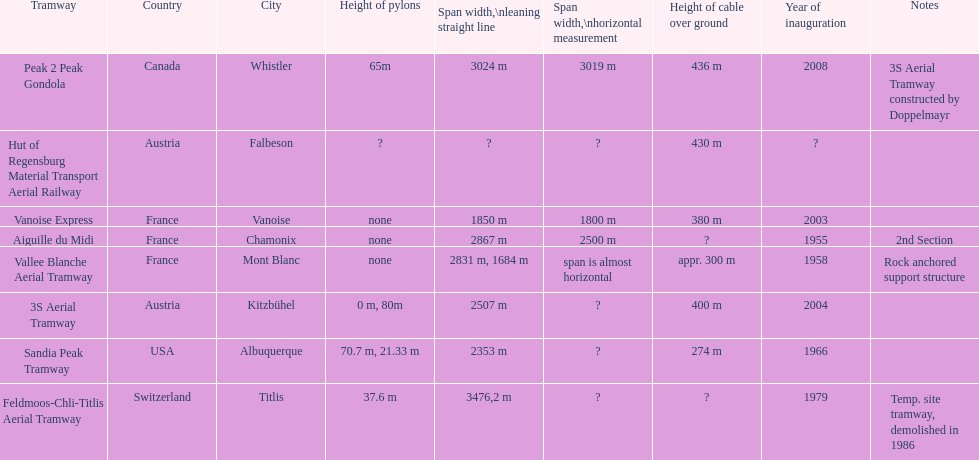Which tramway was established directly before the 3s aerial tramway? Vanoise Express. 